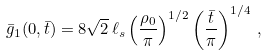Convert formula to latex. <formula><loc_0><loc_0><loc_500><loc_500>\bar { g } _ { 1 } ( 0 , \bar { t } ) = 8 \sqrt { 2 } \, \ell _ { s } \left ( \frac { \rho _ { 0 } } { \pi } \right ) ^ { 1 / 2 } \left ( \frac { \bar { t } } { \pi } \right ) ^ { 1 / 4 } \, ,</formula> 